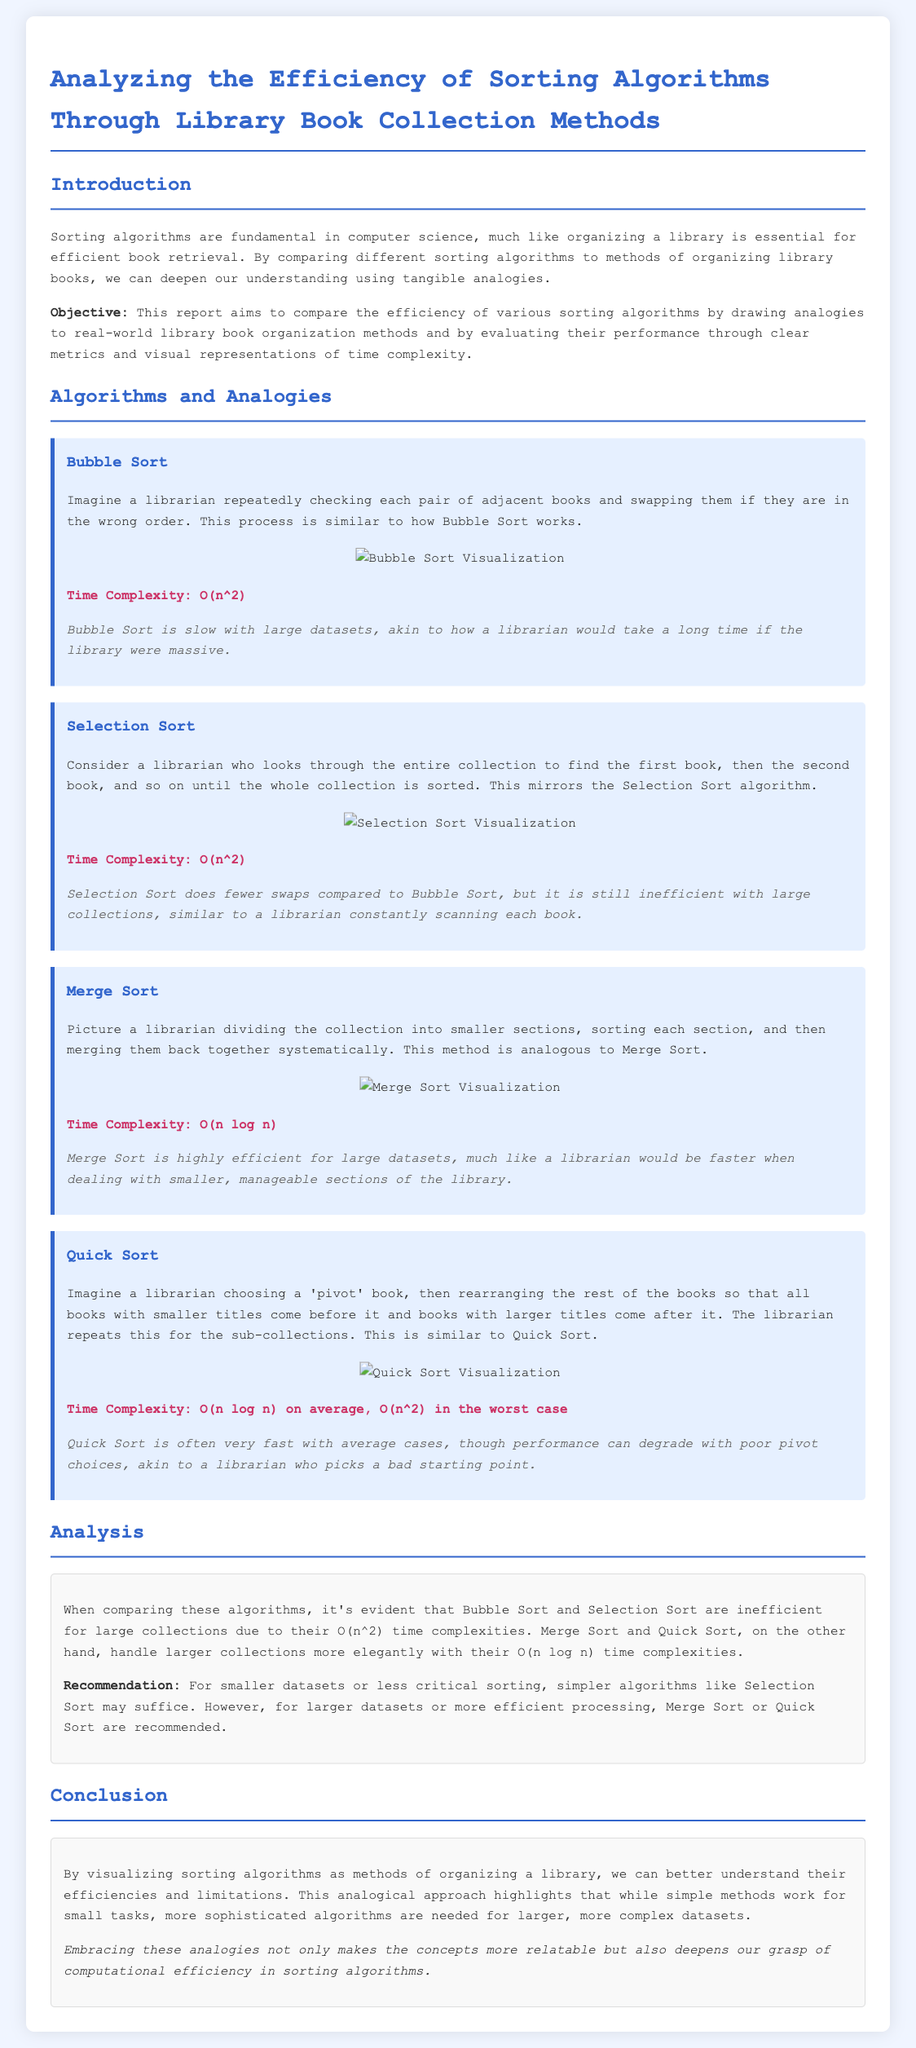What is the time complexity of Bubble Sort? The time complexity of Bubble Sort is stated in the document as O(n^2).
Answer: O(n^2) What analogy is used for Merge Sort? The document compares Merge Sort to a librarian dividing a collection into smaller sections, sorting each section, and then merging them back together.
Answer: Dividing into smaller sections What performance metric is given for Quick Sort in the worst case? The document specifies that Quick Sort has a worst-case time complexity of O(n^2).
Answer: O(n^2) Which sorting algorithm is recommended for larger datasets? The report recommends using Merge Sort or Quick Sort for larger datasets based on their performance metrics.
Answer: Merge Sort or Quick Sort How does Selection Sort compare to Bubble Sort in terms of swaps? The document states that Selection Sort does fewer swaps compared to Bubble Sort.
Answer: Fewer swaps What is the objective of this lab report? The objective of the report aims to compare the efficiency of various sorting algorithms using analogies and performance metrics.
Answer: Compare efficiency of sorting algorithms Which sorting method is described as being akin to a librarian checking pairs of books? The document describes Bubble Sort as similar to a librarian checking pairs of adjacent books.
Answer: Bubble Sort What is the performance description of Merge Sort for large datasets? The document describes Merge Sort as highly efficient for large datasets.
Answer: Highly efficient 